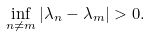<formula> <loc_0><loc_0><loc_500><loc_500>\inf _ { n \neq m } | \lambda _ { n } - \lambda _ { m } | > 0 .</formula> 